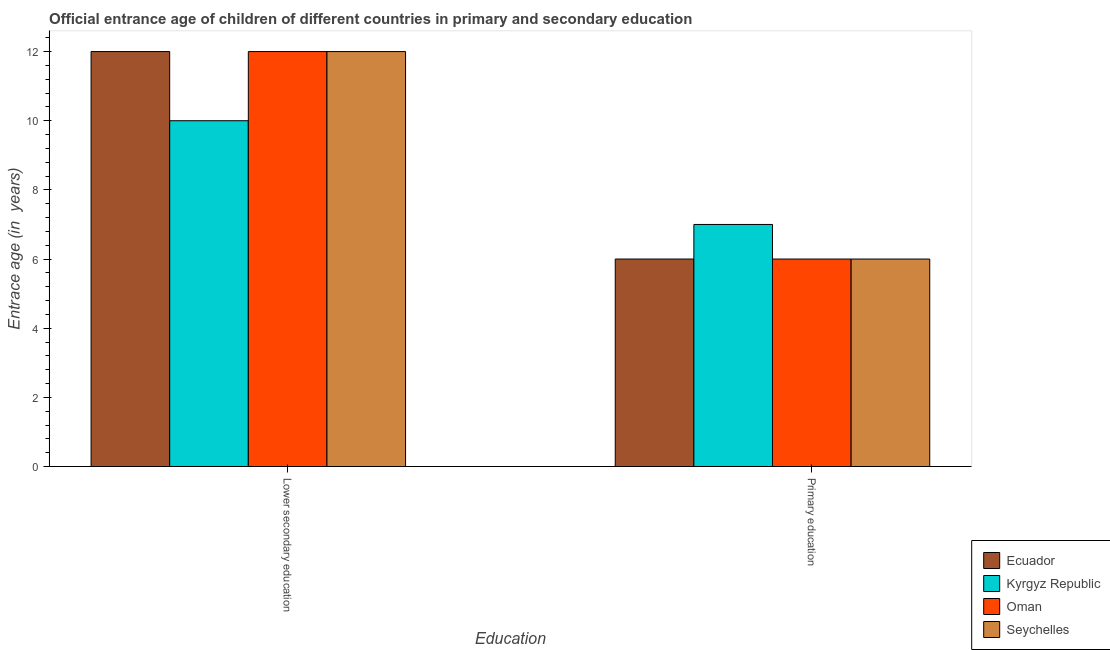How many groups of bars are there?
Ensure brevity in your answer.  2. How many bars are there on the 2nd tick from the left?
Your answer should be very brief. 4. How many bars are there on the 2nd tick from the right?
Provide a succinct answer. 4. What is the label of the 2nd group of bars from the left?
Keep it short and to the point. Primary education. What is the entrance age of children in lower secondary education in Seychelles?
Offer a very short reply. 12. Across all countries, what is the maximum entrance age of children in lower secondary education?
Your answer should be very brief. 12. In which country was the entrance age of chiildren in primary education maximum?
Offer a terse response. Kyrgyz Republic. In which country was the entrance age of chiildren in primary education minimum?
Your answer should be compact. Ecuador. What is the total entrance age of chiildren in primary education in the graph?
Provide a succinct answer. 25. What is the difference between the entrance age of chiildren in primary education in Kyrgyz Republic and that in Oman?
Ensure brevity in your answer.  1. What is the difference between the entrance age of chiildren in primary education in Oman and the entrance age of children in lower secondary education in Ecuador?
Provide a succinct answer. -6. What is the average entrance age of chiildren in primary education per country?
Offer a terse response. 6.25. What is the difference between the entrance age of children in lower secondary education and entrance age of chiildren in primary education in Ecuador?
Ensure brevity in your answer.  6. In how many countries, is the entrance age of chiildren in primary education greater than 9.2 years?
Provide a succinct answer. 0. What is the ratio of the entrance age of children in lower secondary education in Ecuador to that in Kyrgyz Republic?
Offer a terse response. 1.2. What does the 4th bar from the left in Primary education represents?
Make the answer very short. Seychelles. What does the 2nd bar from the right in Lower secondary education represents?
Offer a terse response. Oman. Are all the bars in the graph horizontal?
Provide a succinct answer. No. What is the difference between two consecutive major ticks on the Y-axis?
Offer a very short reply. 2. Are the values on the major ticks of Y-axis written in scientific E-notation?
Make the answer very short. No. Where does the legend appear in the graph?
Make the answer very short. Bottom right. How are the legend labels stacked?
Your answer should be very brief. Vertical. What is the title of the graph?
Your response must be concise. Official entrance age of children of different countries in primary and secondary education. What is the label or title of the X-axis?
Keep it short and to the point. Education. What is the label or title of the Y-axis?
Offer a terse response. Entrace age (in  years). What is the Entrace age (in  years) of Oman in Lower secondary education?
Your answer should be compact. 12. What is the Entrace age (in  years) in Seychelles in Lower secondary education?
Ensure brevity in your answer.  12. What is the Entrace age (in  years) in Kyrgyz Republic in Primary education?
Offer a terse response. 7. Across all Education, what is the maximum Entrace age (in  years) in Oman?
Keep it short and to the point. 12. Across all Education, what is the minimum Entrace age (in  years) in Seychelles?
Provide a short and direct response. 6. What is the total Entrace age (in  years) in Ecuador in the graph?
Give a very brief answer. 18. What is the total Entrace age (in  years) in Oman in the graph?
Keep it short and to the point. 18. What is the total Entrace age (in  years) in Seychelles in the graph?
Ensure brevity in your answer.  18. What is the difference between the Entrace age (in  years) in Kyrgyz Republic in Lower secondary education and that in Primary education?
Your answer should be compact. 3. What is the difference between the Entrace age (in  years) in Oman in Lower secondary education and the Entrace age (in  years) in Seychelles in Primary education?
Make the answer very short. 6. What is the average Entrace age (in  years) in Ecuador per Education?
Give a very brief answer. 9. What is the average Entrace age (in  years) of Oman per Education?
Offer a terse response. 9. What is the difference between the Entrace age (in  years) of Ecuador and Entrace age (in  years) of Seychelles in Lower secondary education?
Provide a succinct answer. 0. What is the difference between the Entrace age (in  years) in Kyrgyz Republic and Entrace age (in  years) in Seychelles in Lower secondary education?
Give a very brief answer. -2. What is the difference between the Entrace age (in  years) in Oman and Entrace age (in  years) in Seychelles in Lower secondary education?
Your response must be concise. 0. What is the difference between the Entrace age (in  years) of Ecuador and Entrace age (in  years) of Kyrgyz Republic in Primary education?
Your response must be concise. -1. What is the difference between the Entrace age (in  years) of Kyrgyz Republic and Entrace age (in  years) of Oman in Primary education?
Your response must be concise. 1. What is the difference between the Entrace age (in  years) of Kyrgyz Republic and Entrace age (in  years) of Seychelles in Primary education?
Your response must be concise. 1. What is the difference between the Entrace age (in  years) of Oman and Entrace age (in  years) of Seychelles in Primary education?
Your answer should be compact. 0. What is the ratio of the Entrace age (in  years) of Kyrgyz Republic in Lower secondary education to that in Primary education?
Your answer should be compact. 1.43. What is the ratio of the Entrace age (in  years) in Oman in Lower secondary education to that in Primary education?
Provide a succinct answer. 2. What is the ratio of the Entrace age (in  years) in Seychelles in Lower secondary education to that in Primary education?
Offer a terse response. 2. What is the difference between the highest and the second highest Entrace age (in  years) in Kyrgyz Republic?
Give a very brief answer. 3. What is the difference between the highest and the second highest Entrace age (in  years) of Oman?
Your response must be concise. 6. What is the difference between the highest and the second highest Entrace age (in  years) of Seychelles?
Give a very brief answer. 6. What is the difference between the highest and the lowest Entrace age (in  years) of Ecuador?
Ensure brevity in your answer.  6. What is the difference between the highest and the lowest Entrace age (in  years) in Oman?
Make the answer very short. 6. What is the difference between the highest and the lowest Entrace age (in  years) of Seychelles?
Make the answer very short. 6. 